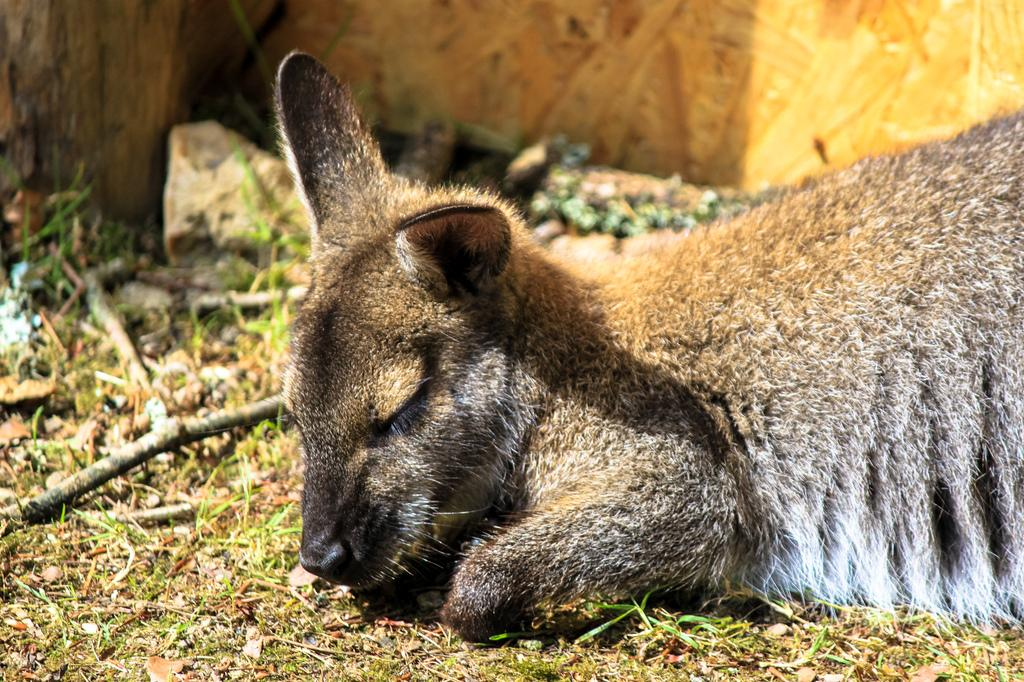What is the animal lying on the floor in the image? The facts provided do not specify the type of animal. Can you describe the background of the image? There is a stone visible in the background of the image. What hobbies does the animal have, as seen in the image? The facts provided do not mention any hobbies of the animal, nor is there any indication of the animal's hobbies in the image. 